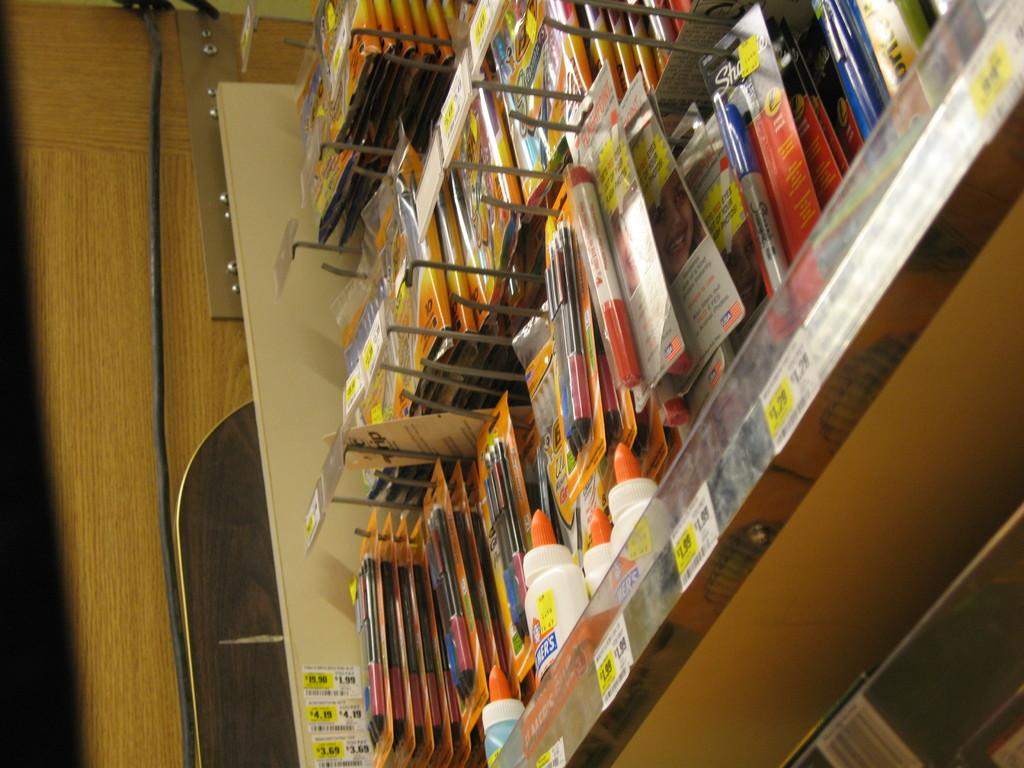What objects are on the rack in the image? There are bottles and packets on the rack. Are there any decorations on the rack? Yes, stickers are pasted on the rack. How many leaves can be seen on the rack in the image? There are no leaves present on the rack in the image. What type of sweater is hanging on the rack? There is no sweater present on the rack in the image. 